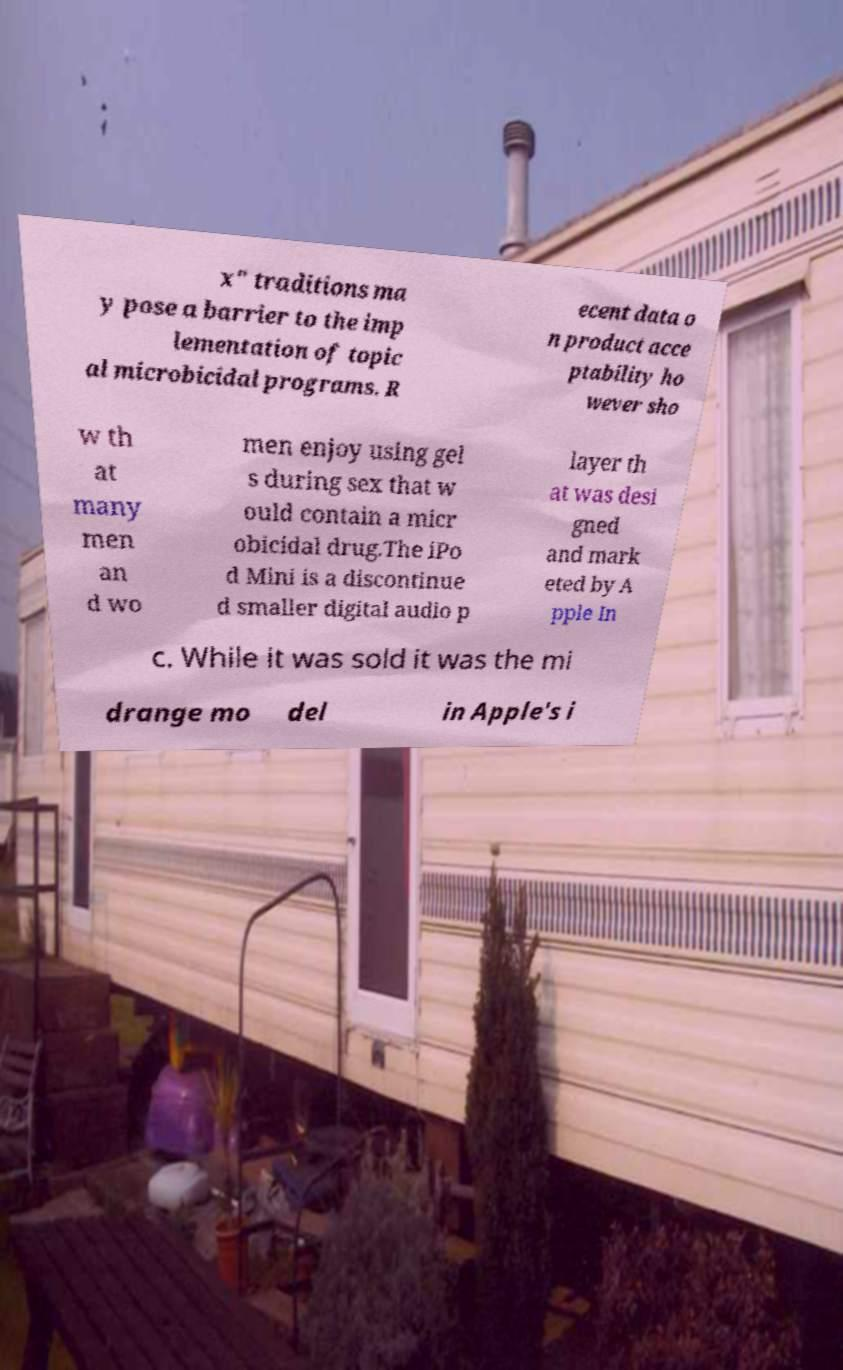I need the written content from this picture converted into text. Can you do that? x" traditions ma y pose a barrier to the imp lementation of topic al microbicidal programs. R ecent data o n product acce ptability ho wever sho w th at many men an d wo men enjoy using gel s during sex that w ould contain a micr obicidal drug.The iPo d Mini is a discontinue d smaller digital audio p layer th at was desi gned and mark eted by A pple In c. While it was sold it was the mi drange mo del in Apple's i 